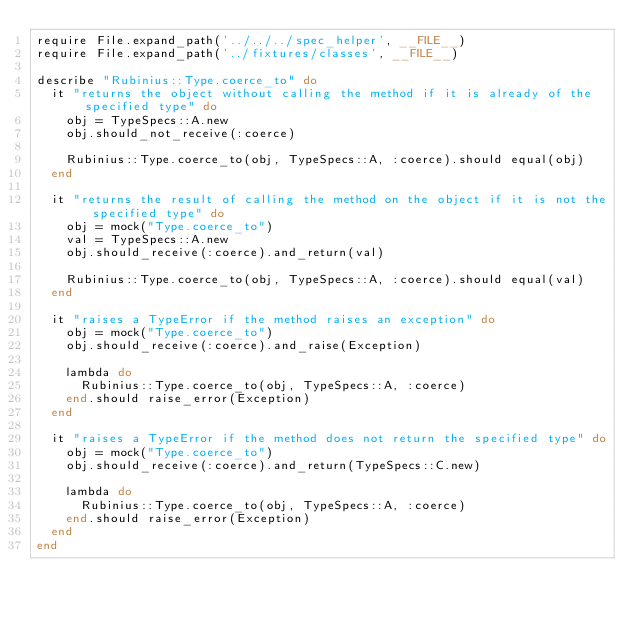<code> <loc_0><loc_0><loc_500><loc_500><_Ruby_>require File.expand_path('../../../spec_helper', __FILE__)
require File.expand_path('../fixtures/classes', __FILE__)

describe "Rubinius::Type.coerce_to" do
  it "returns the object without calling the method if it is already of the specified type" do
    obj = TypeSpecs::A.new
    obj.should_not_receive(:coerce)

    Rubinius::Type.coerce_to(obj, TypeSpecs::A, :coerce).should equal(obj)
  end

  it "returns the result of calling the method on the object if it is not the specified type" do
    obj = mock("Type.coerce_to")
    val = TypeSpecs::A.new
    obj.should_receive(:coerce).and_return(val)

    Rubinius::Type.coerce_to(obj, TypeSpecs::A, :coerce).should equal(val)
  end

  it "raises a TypeError if the method raises an exception" do
    obj = mock("Type.coerce_to")
    obj.should_receive(:coerce).and_raise(Exception)

    lambda do
      Rubinius::Type.coerce_to(obj, TypeSpecs::A, :coerce)
    end.should raise_error(Exception)
  end

  it "raises a TypeError if the method does not return the specified type" do
    obj = mock("Type.coerce_to")
    obj.should_receive(:coerce).and_return(TypeSpecs::C.new)

    lambda do
      Rubinius::Type.coerce_to(obj, TypeSpecs::A, :coerce)
    end.should raise_error(Exception)
  end
end
</code> 